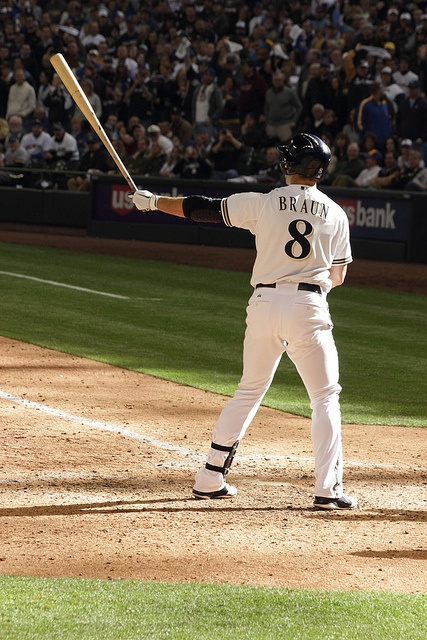Describe the objects in this image and their specific colors. I can see people in black, gray, and maroon tones, people in black, tan, white, and darkgray tones, people in black, gray, and maroon tones, baseball bat in black, tan, white, and olive tones, and people in black and gray tones in this image. 